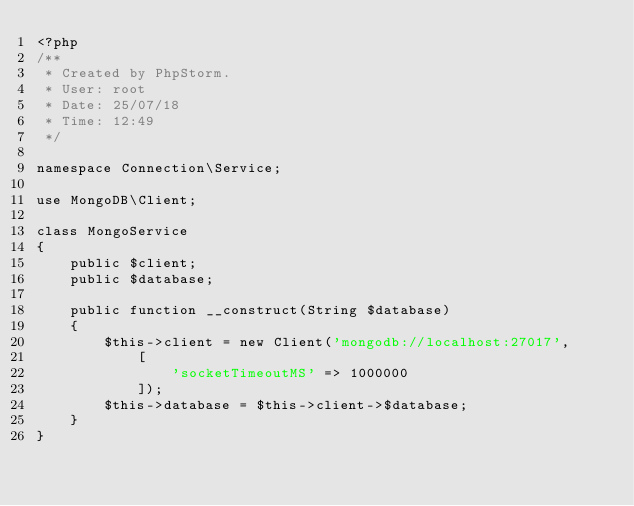<code> <loc_0><loc_0><loc_500><loc_500><_PHP_><?php
/**
 * Created by PhpStorm.
 * User: root
 * Date: 25/07/18
 * Time: 12:49
 */

namespace Connection\Service;

use MongoDB\Client;

class MongoService
{
    public $client;
    public $database;

    public function __construct(String $database)
    {
        $this->client = new Client('mongodb://localhost:27017',
            [
                'socketTimeoutMS' => 1000000
            ]);
        $this->database = $this->client->$database;
    }
}</code> 